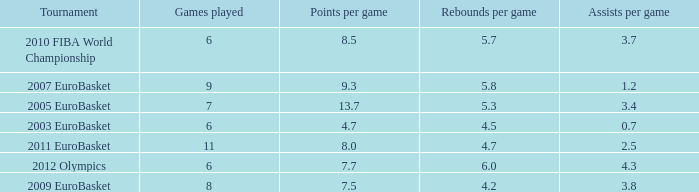How many games played have 4.7 as points per game? 6.0. 